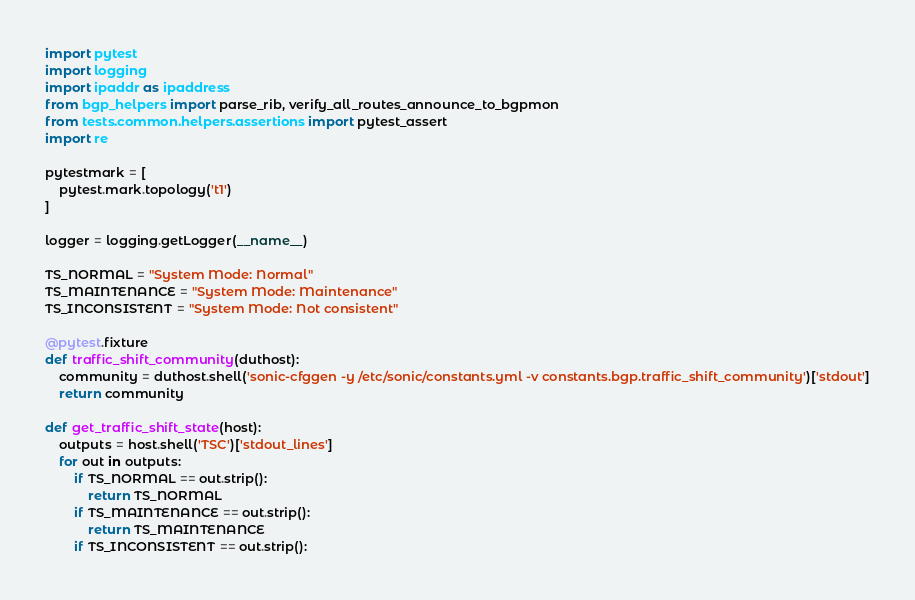<code> <loc_0><loc_0><loc_500><loc_500><_Python_>import pytest
import logging
import ipaddr as ipaddress
from bgp_helpers import parse_rib, verify_all_routes_announce_to_bgpmon 
from tests.common.helpers.assertions import pytest_assert
import re

pytestmark = [
    pytest.mark.topology('t1')
]

logger = logging.getLogger(__name__)

TS_NORMAL = "System Mode: Normal"
TS_MAINTENANCE = "System Mode: Maintenance"
TS_INCONSISTENT = "System Mode: Not consistent"

@pytest.fixture
def traffic_shift_community(duthost):
    community = duthost.shell('sonic-cfggen -y /etc/sonic/constants.yml -v constants.bgp.traffic_shift_community')['stdout']
    return community

def get_traffic_shift_state(host):
    outputs = host.shell('TSC')['stdout_lines']
    for out in outputs:
        if TS_NORMAL == out.strip():
            return TS_NORMAL
        if TS_MAINTENANCE == out.strip():
            return TS_MAINTENANCE
        if TS_INCONSISTENT == out.strip():</code> 